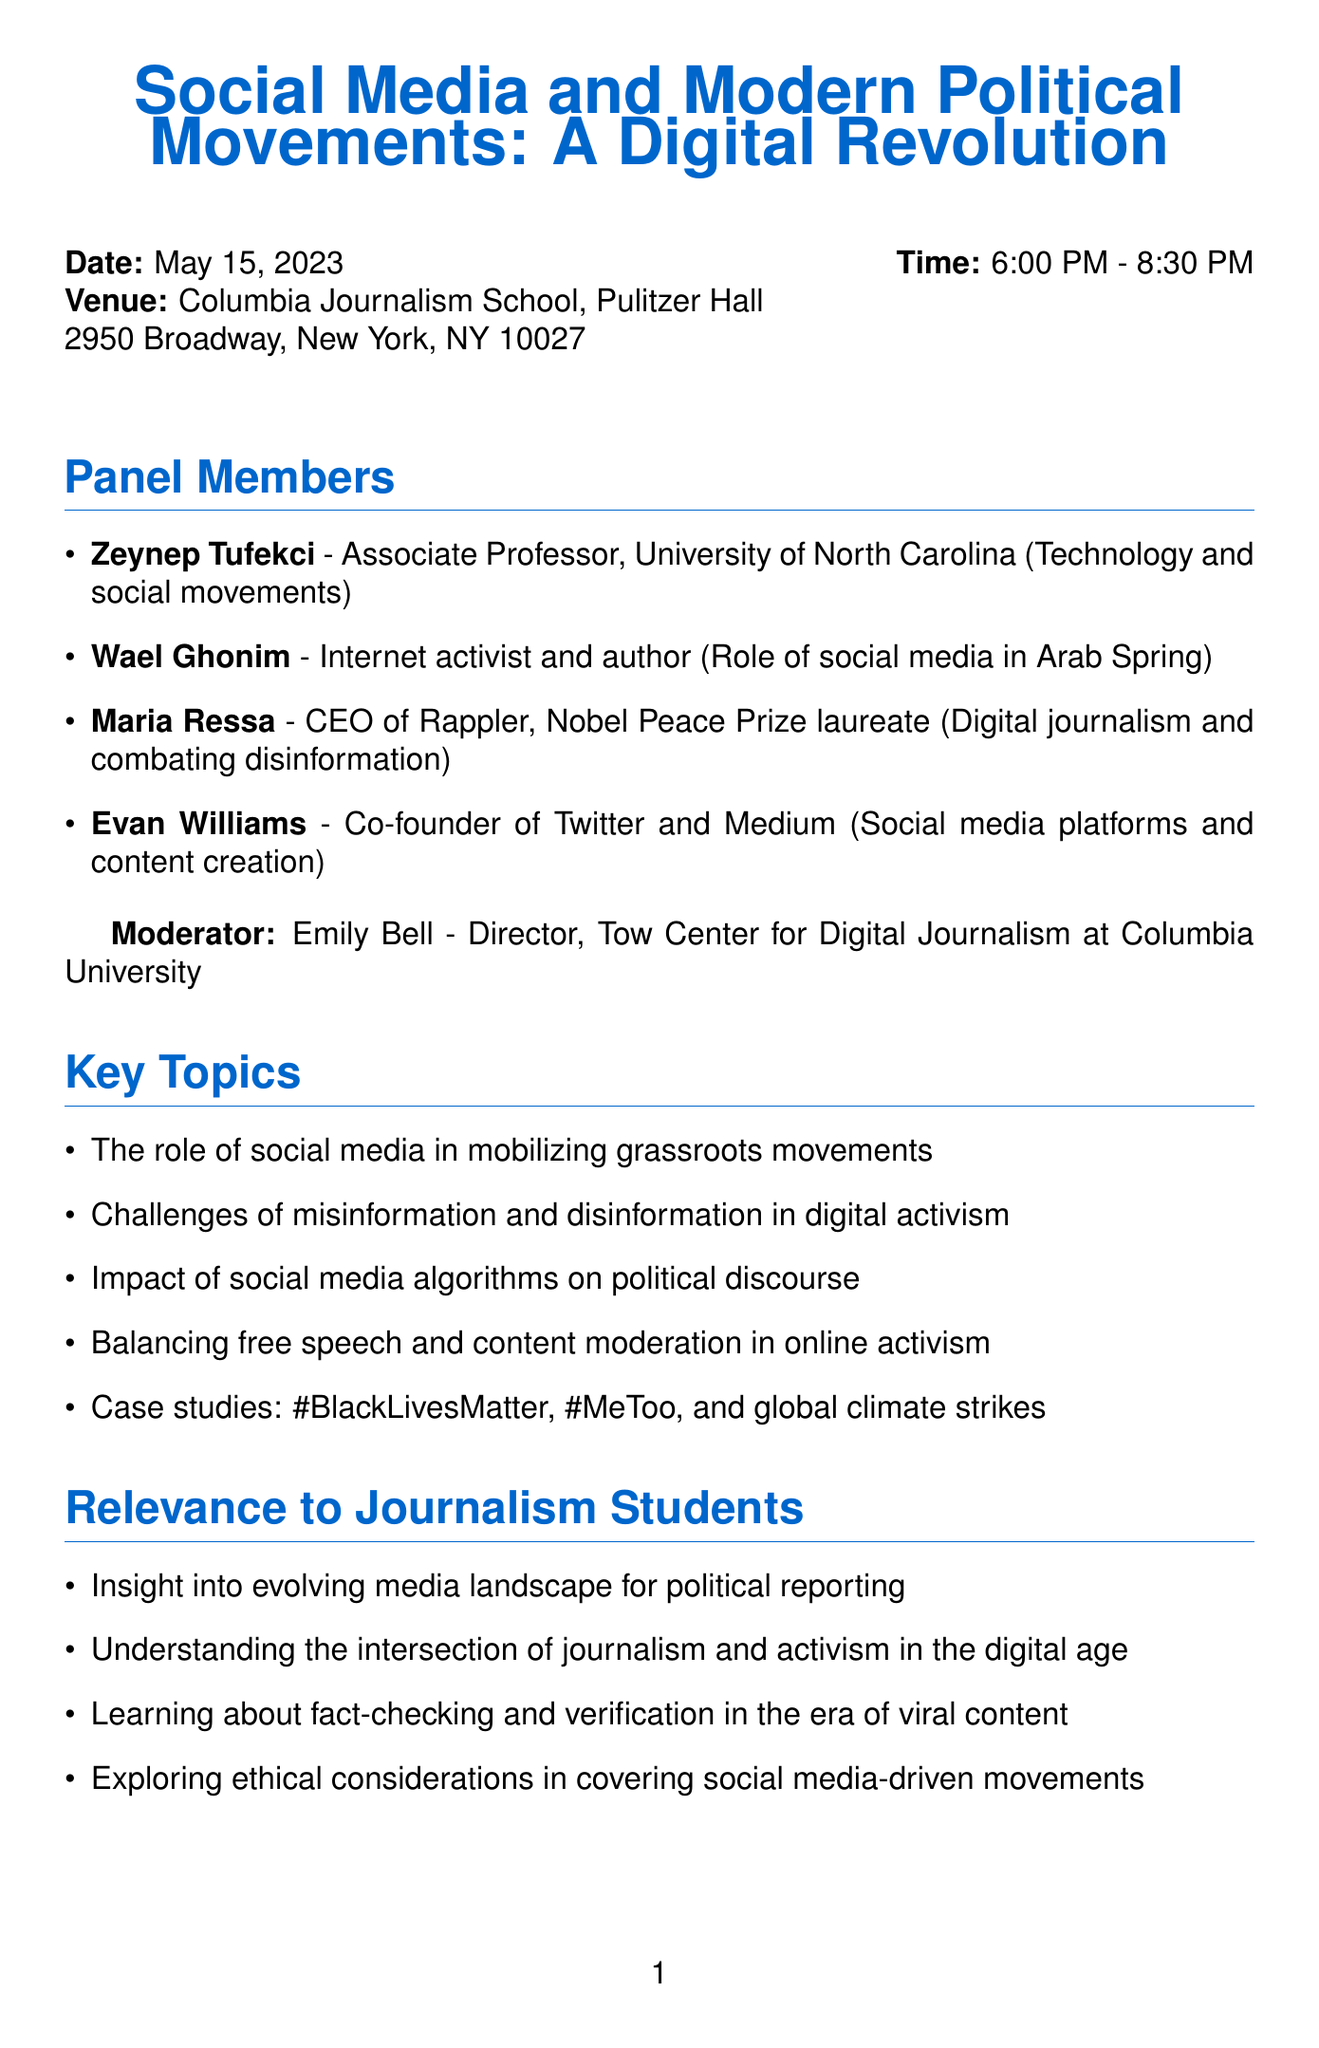What is the title of the event? The title of the event is presented at the beginning of the document as "Social Media and Modern Political Movements: A Digital Revolution."
Answer: Social Media and Modern Political Movements: A Digital Revolution When is the event scheduled? The date of the event is specified in the document as May 15, 2023.
Answer: May 15, 2023 Who is moderating the panel discussion? The moderator of the panel is identified in the document as Emily Bell.
Answer: Emily Bell What is the focus of the panel discussion? The document lists key topics, including the role of social media in mobilizing grassroots movements, indicating the focus area.
Answer: Role of social media in mobilizing grassroots movements What is the registration deadline? The deadline for registration is clearly stated in the document as May 10, 2023.
Answer: May 10, 2023 Which panelist is a Nobel Peace Prize laureate? The document specifically mentions Maria Ressa as a Nobel Peace Prize laureate among the panelists.
Answer: Maria Ressa What is one of the challenges discussed in the panel? One challenge listed in the document is the challenges of misinformation and disinformation in digital activism.
Answer: Misinformation and disinformation What is the registration method? The document describes the registration method as "Online registration via Columbia Journalism School website."
Answer: Online registration via Columbia Journalism School website What networking opportunity is provided after the panel? The document mentions a post-panel reception with light refreshments for attendees to interact.
Answer: Post-panel reception with light refreshments 